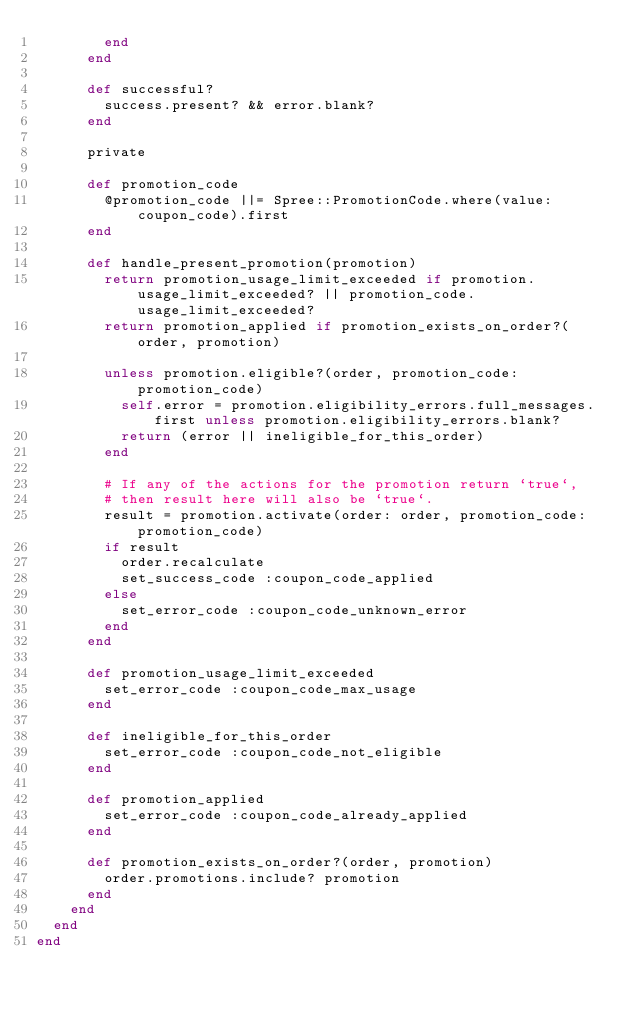Convert code to text. <code><loc_0><loc_0><loc_500><loc_500><_Ruby_>        end
      end

      def successful?
        success.present? && error.blank?
      end

      private

      def promotion_code
        @promotion_code ||= Spree::PromotionCode.where(value: coupon_code).first
      end

      def handle_present_promotion(promotion)
        return promotion_usage_limit_exceeded if promotion.usage_limit_exceeded? || promotion_code.usage_limit_exceeded?
        return promotion_applied if promotion_exists_on_order?(order, promotion)

        unless promotion.eligible?(order, promotion_code: promotion_code)
          self.error = promotion.eligibility_errors.full_messages.first unless promotion.eligibility_errors.blank?
          return (error || ineligible_for_this_order)
        end

        # If any of the actions for the promotion return `true`,
        # then result here will also be `true`.
        result = promotion.activate(order: order, promotion_code: promotion_code)
        if result
          order.recalculate
          set_success_code :coupon_code_applied
        else
          set_error_code :coupon_code_unknown_error
        end
      end

      def promotion_usage_limit_exceeded
        set_error_code :coupon_code_max_usage
      end

      def ineligible_for_this_order
        set_error_code :coupon_code_not_eligible
      end

      def promotion_applied
        set_error_code :coupon_code_already_applied
      end

      def promotion_exists_on_order?(order, promotion)
        order.promotions.include? promotion
      end
    end
  end
end
</code> 